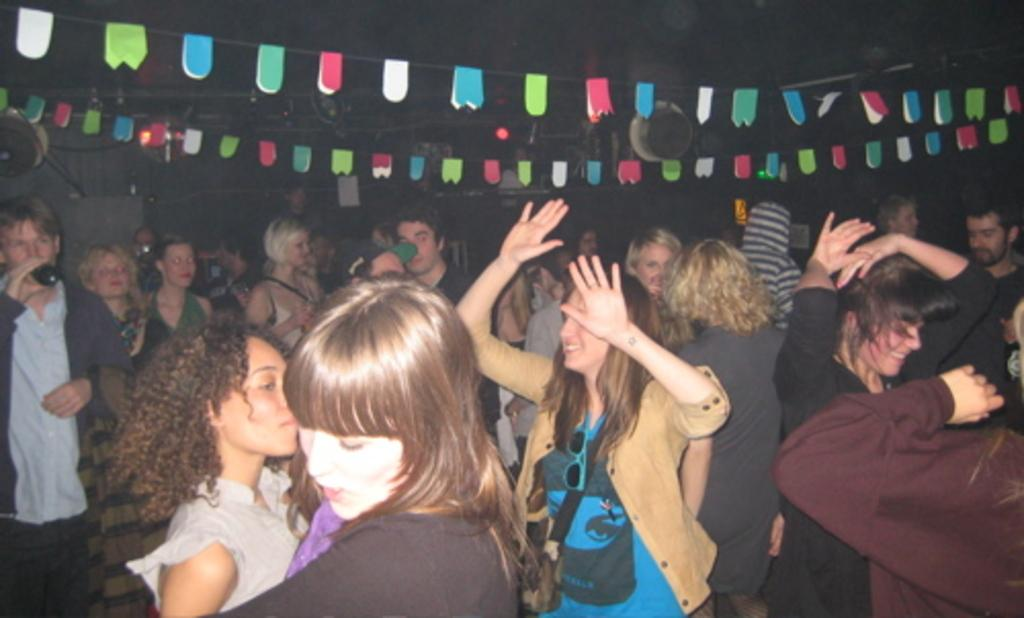How many people are in the image? There is a group of people in the image. What is one man doing with his hand? One man is holding a bottle in his hand. What activity are some people engaged in? Some people are dancing. What can be observed about the lighting in the image? The background of the image is dark. What type of floor can be seen in the image? There is no specific floor mentioned or visible in the image. Is there a birthday celebration happening in the image? There is no indication of a birthday celebration in the image. What reward is being given to the dancers in the image? There is no reward being given to the dancers in the image; they are simply dancing. 